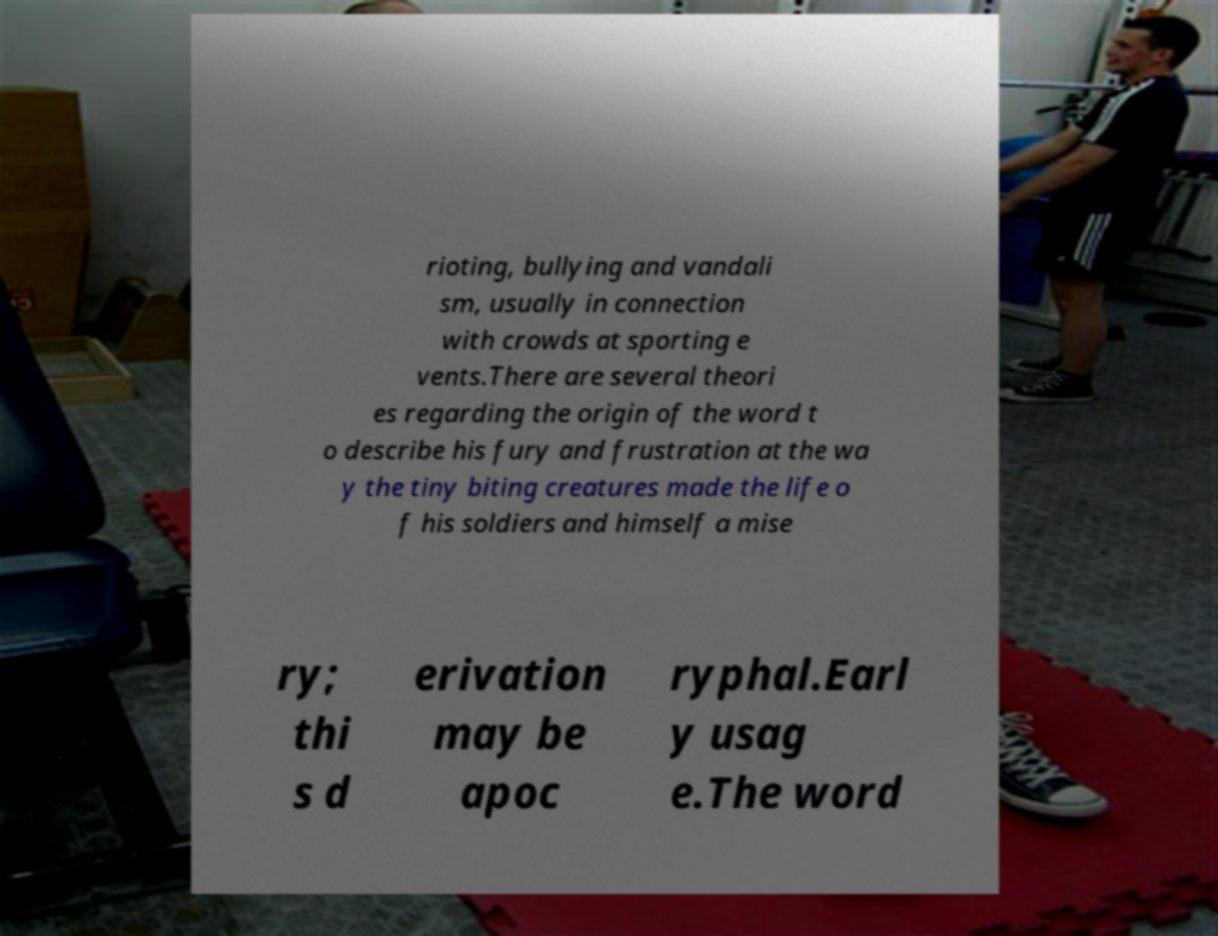Can you accurately transcribe the text from the provided image for me? rioting, bullying and vandali sm, usually in connection with crowds at sporting e vents.There are several theori es regarding the origin of the word t o describe his fury and frustration at the wa y the tiny biting creatures made the life o f his soldiers and himself a mise ry; thi s d erivation may be apoc ryphal.Earl y usag e.The word 